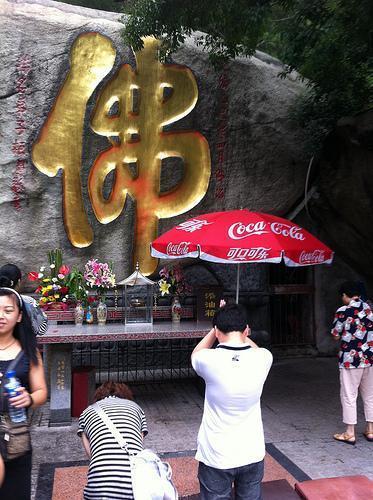How many umbrellas are in the photo?
Give a very brief answer. 1. How many people are in the photo?
Give a very brief answer. 5. 